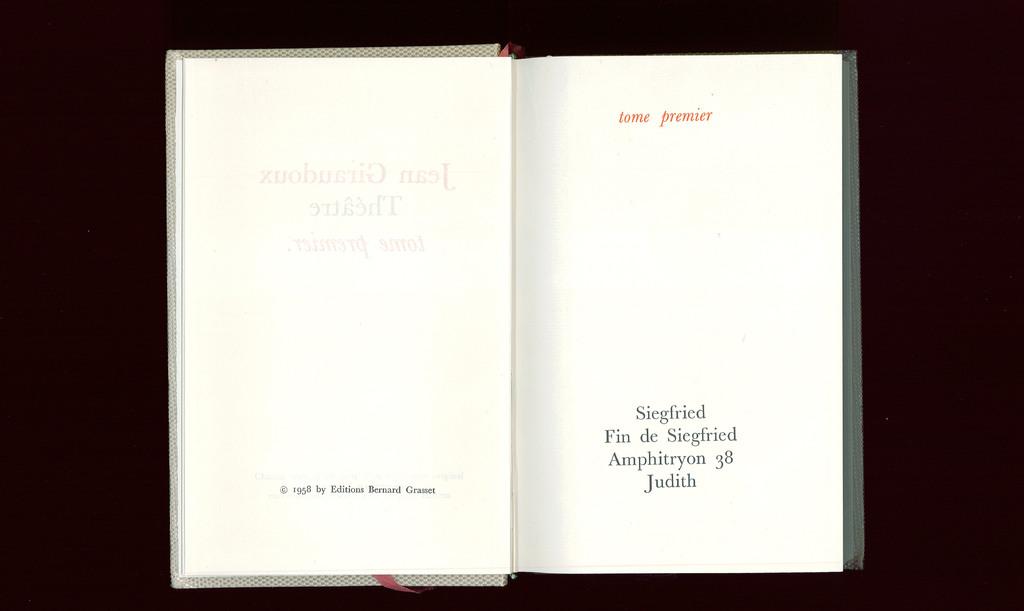What is the right text in book?
Your answer should be very brief. Tome premier. 